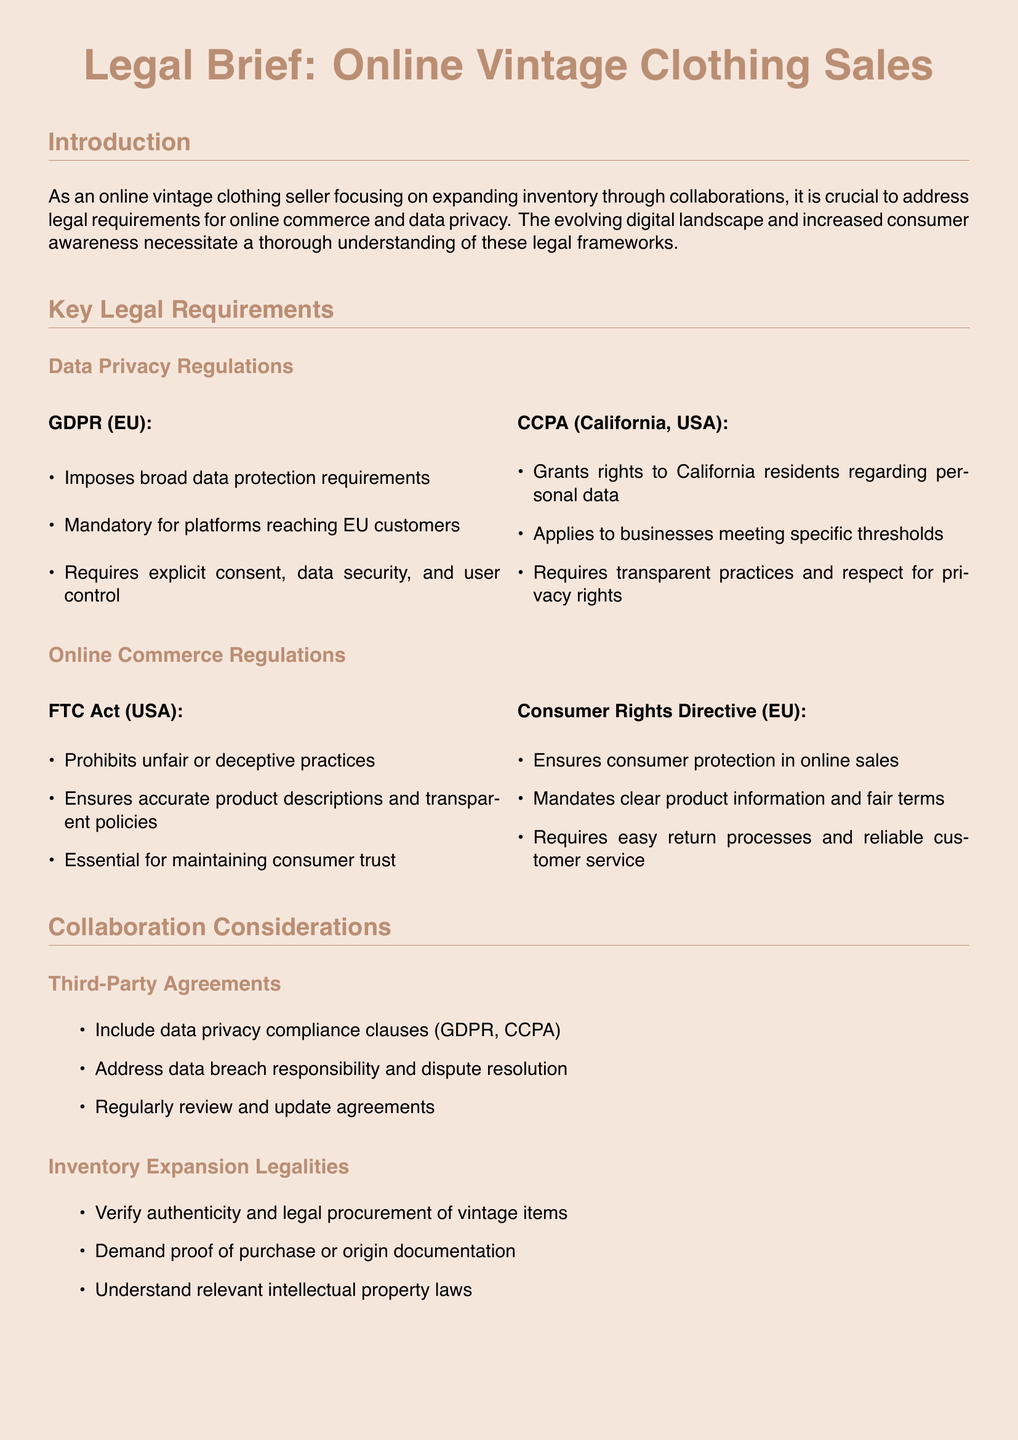What is the title of the document? The title is prominently stated at the beginning of the document, which is "Legal Brief: Online Vintage Clothing Sales."
Answer: Legal Brief: Online Vintage Clothing Sales What regulations does GDPR pertain to? GDPR imposes broad data protection requirements and is mandatory for platforms reaching EU customers.
Answer: EU What does CCPA stand for? CCPA is an acronym used in the document that stands for California Consumer Privacy Act.
Answer: California Consumer Privacy Act What is prohibited by the FTC Act? The document states that the FTC Act prohibits unfair or deceptive practices in online commerce.
Answer: Unfair or deceptive practices What must third-party agreements include? According to the document, third-party agreements must include data privacy compliance clauses.
Answer: Data privacy compliance clauses What consumer rights does the Consumer Rights Directive ensure? The Consumer Rights Directive ensures consumer protection in online sales and fair terms.
Answer: Consumer protection How many legal requirements are listed under Data Privacy Regulations? The document lists two major data privacy regulations: GDPR and CCPA.
Answer: Two What must be verified in inventory expansion legalities? The document states that it is essential to verify the authenticity and legal procurement of vintage items.
Answer: Authenticity and legal procurement What is necessary for maintaining consumer trust according to the FTC Act? The document emphasizes that accurate product descriptions and transparent policies are necessary for maintaining consumer trust.
Answer: Accurate product descriptions and transparent policies 